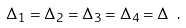<formula> <loc_0><loc_0><loc_500><loc_500>\Delta _ { 1 } = \Delta _ { 2 } = \Delta _ { 3 } = \Delta _ { 4 } = \Delta \ .</formula> 